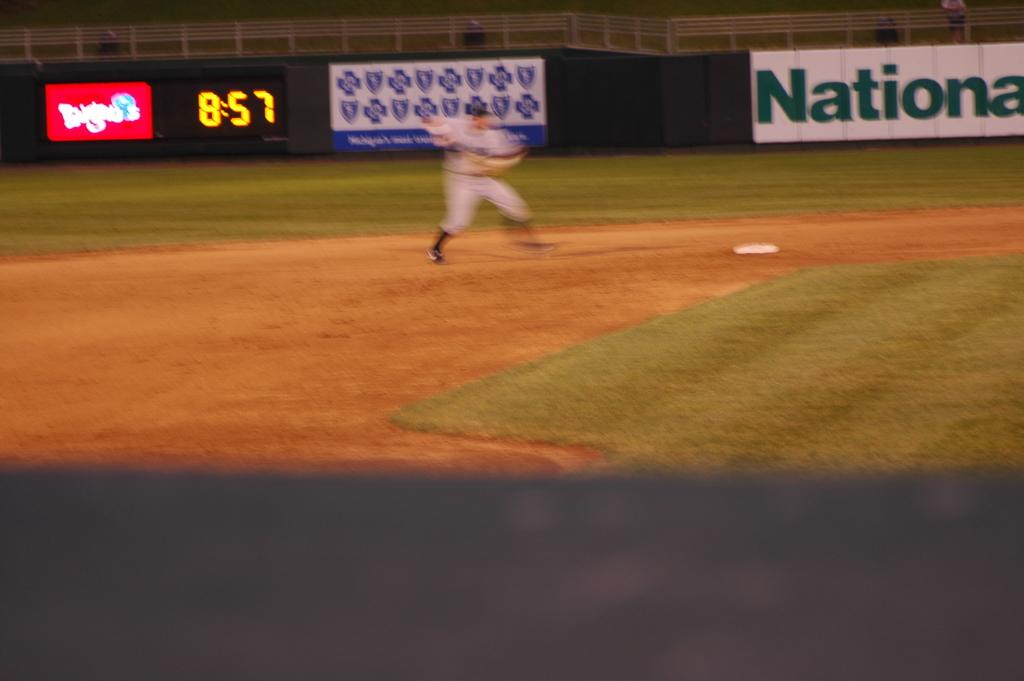<image>
Offer a succinct explanation of the picture presented. The clock behind the baseball player indicates it is 8:57. 